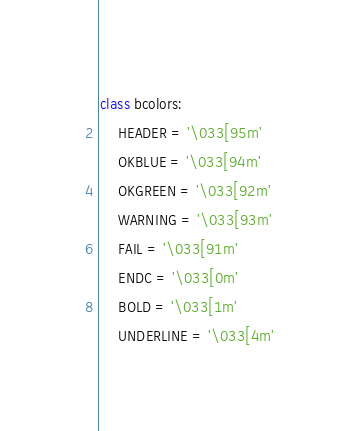Convert code to text. <code><loc_0><loc_0><loc_500><loc_500><_Python_>class bcolors:
    HEADER = '\033[95m'
    OKBLUE = '\033[94m'
    OKGREEN = '\033[92m'
    WARNING = '\033[93m'
    FAIL = '\033[91m'
    ENDC = '\033[0m'
    BOLD = '\033[1m'
    UNDERLINE = '\033[4m'

</code> 